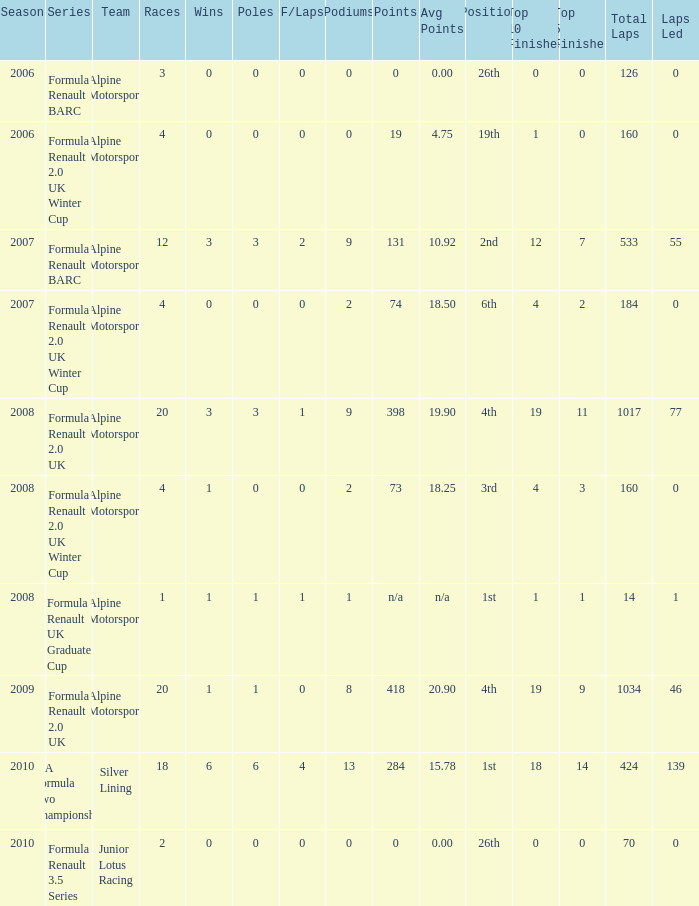During which earliest season did the podium reach a total of 9? 2007.0. 